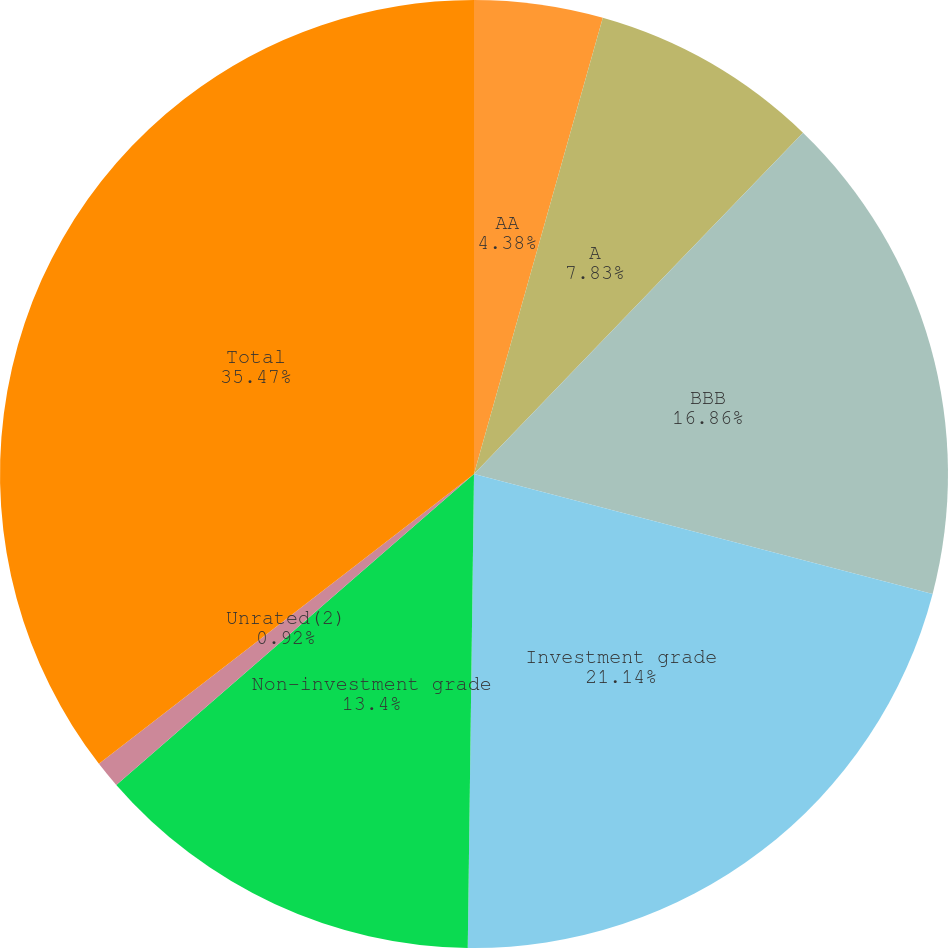<chart> <loc_0><loc_0><loc_500><loc_500><pie_chart><fcel>AA<fcel>A<fcel>BBB<fcel>Investment grade<fcel>Non-investment grade<fcel>Unrated(2)<fcel>Total<nl><fcel>4.38%<fcel>7.83%<fcel>16.86%<fcel>21.14%<fcel>13.4%<fcel>0.92%<fcel>35.47%<nl></chart> 